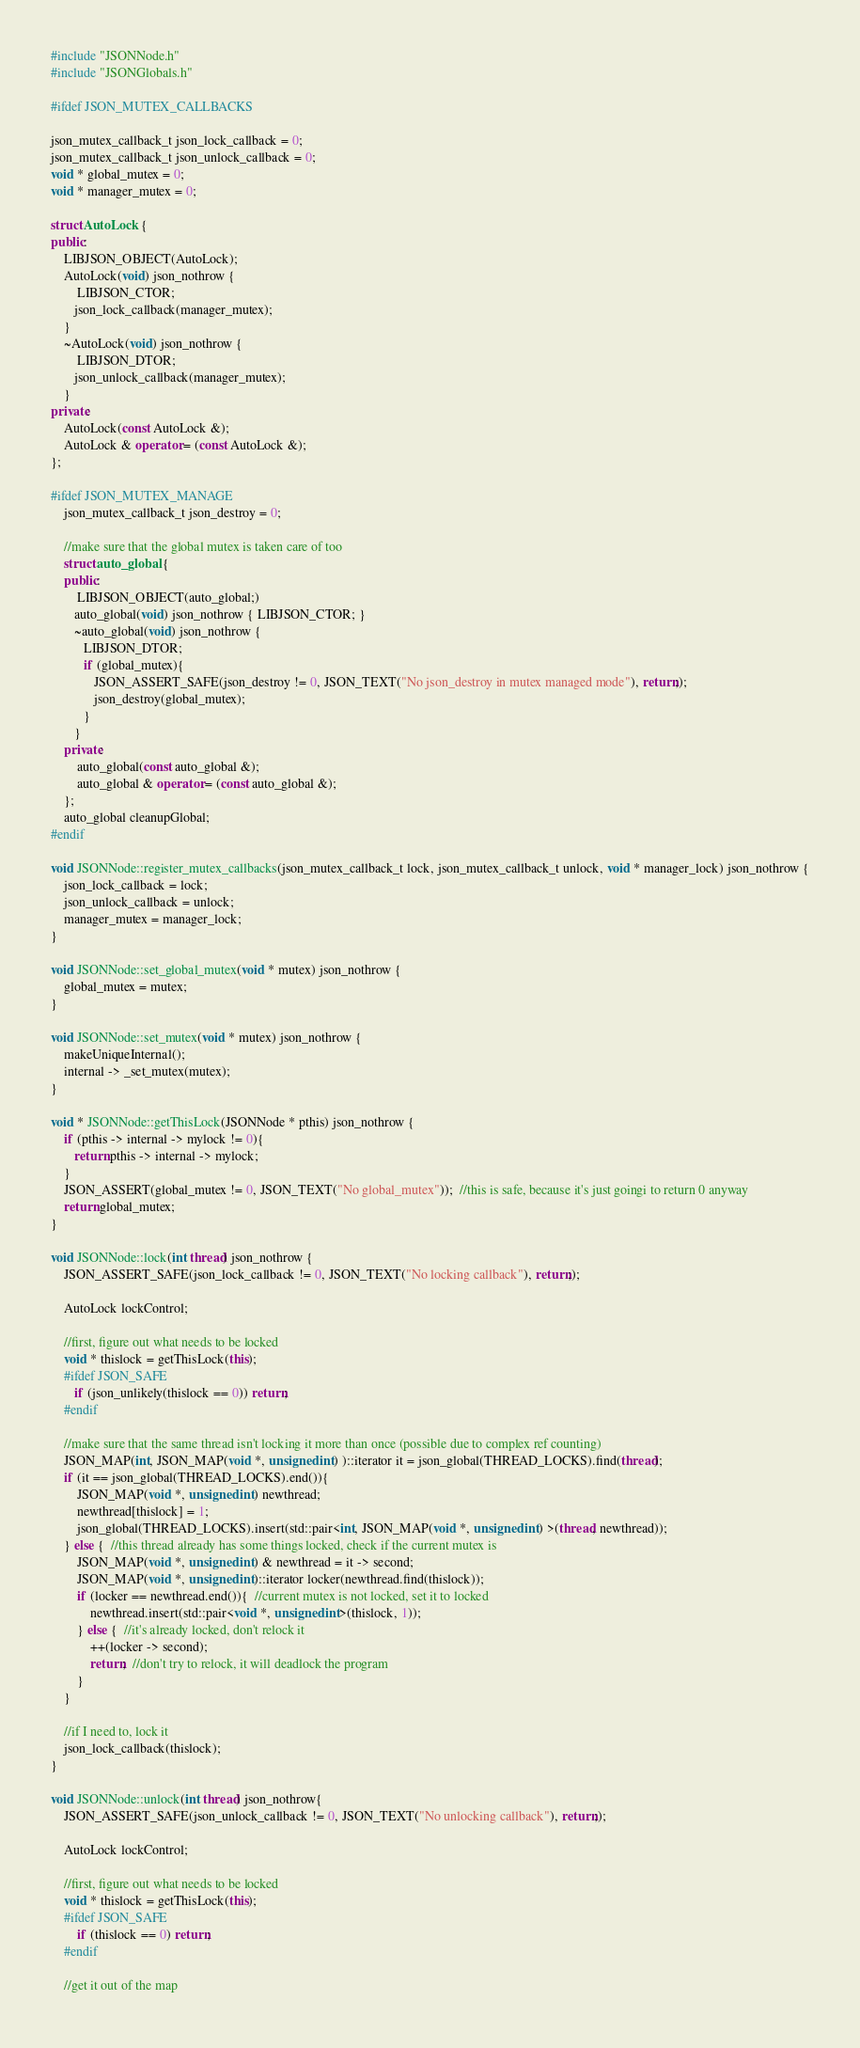<code> <loc_0><loc_0><loc_500><loc_500><_C++_>#include "JSONNode.h"
#include "JSONGlobals.h"

#ifdef JSON_MUTEX_CALLBACKS

json_mutex_callback_t json_lock_callback = 0;
json_mutex_callback_t json_unlock_callback = 0;
void * global_mutex = 0;
void * manager_mutex = 0;

struct AutoLock {
public:
	LIBJSON_OBJECT(AutoLock);
    AutoLock(void) json_nothrow {
		LIBJSON_CTOR;
	   json_lock_callback(manager_mutex);
    }
    ~AutoLock(void) json_nothrow {
		LIBJSON_DTOR;
	   json_unlock_callback(manager_mutex);
    }
private:
    AutoLock(const AutoLock &);
    AutoLock & operator = (const AutoLock &);
};

#ifdef JSON_MUTEX_MANAGE
    json_mutex_callback_t json_destroy = 0;

    //make sure that the global mutex is taken care of too
    struct auto_global {
    public:
		LIBJSON_OBJECT(auto_global;)
	   auto_global(void) json_nothrow { LIBJSON_CTOR; }
	   ~auto_global(void) json_nothrow {
		  LIBJSON_DTOR;
		  if (global_mutex){
			 JSON_ASSERT_SAFE(json_destroy != 0, JSON_TEXT("No json_destroy in mutex managed mode"), return;);
			 json_destroy(global_mutex);
		  }
	   }
    private:
        auto_global(const auto_global &);
        auto_global & operator = (const auto_global &);
    };
    auto_global cleanupGlobal;
#endif

void JSONNode::register_mutex_callbacks(json_mutex_callback_t lock, json_mutex_callback_t unlock, void * manager_lock) json_nothrow {
    json_lock_callback = lock;
    json_unlock_callback = unlock;
    manager_mutex = manager_lock;
}

void JSONNode::set_global_mutex(void * mutex) json_nothrow {
    global_mutex = mutex;
}

void JSONNode::set_mutex(void * mutex) json_nothrow {
    makeUniqueInternal();
    internal -> _set_mutex(mutex);
}

void * JSONNode::getThisLock(JSONNode * pthis) json_nothrow {
    if (pthis -> internal -> mylock != 0){
	   return pthis -> internal -> mylock;
    }
    JSON_ASSERT(global_mutex != 0, JSON_TEXT("No global_mutex"));  //this is safe, because it's just goingi to return 0 anyway
    return global_mutex;
}

void JSONNode::lock(int thread) json_nothrow {
    JSON_ASSERT_SAFE(json_lock_callback != 0, JSON_TEXT("No locking callback"), return;);

    AutoLock lockControl;

    //first, figure out what needs to be locked
    void * thislock = getThisLock(this);
    #ifdef JSON_SAFE
	   if (json_unlikely(thislock == 0)) return;
    #endif

    //make sure that the same thread isn't locking it more than once (possible due to complex ref counting)
    JSON_MAP(int, JSON_MAP(void *, unsigned int) )::iterator it = json_global(THREAD_LOCKS).find(thread);
    if (it == json_global(THREAD_LOCKS).end()){
		JSON_MAP(void *, unsigned int) newthread;
		newthread[thislock] = 1;
		json_global(THREAD_LOCKS).insert(std::pair<int, JSON_MAP(void *, unsigned int) >(thread, newthread));
    } else {  //this thread already has some things locked, check if the current mutex is
		JSON_MAP(void *, unsigned int) & newthread = it -> second;
		JSON_MAP(void *, unsigned int)::iterator locker(newthread.find(thislock));
		if (locker == newthread.end()){  //current mutex is not locked, set it to locked
			newthread.insert(std::pair<void *, unsigned int>(thislock, 1));
		} else {  //it's already locked, don't relock it
			++(locker -> second);
			return;  //don't try to relock, it will deadlock the program
		}
    }

    //if I need to, lock it
    json_lock_callback(thislock);
}

void JSONNode::unlock(int thread) json_nothrow{
    JSON_ASSERT_SAFE(json_unlock_callback != 0, JSON_TEXT("No unlocking callback"), return;);

    AutoLock lockControl;

    //first, figure out what needs to be locked
    void * thislock = getThisLock(this);
	#ifdef JSON_SAFE
		if (thislock == 0) return;
	#endif

    //get it out of the map</code> 